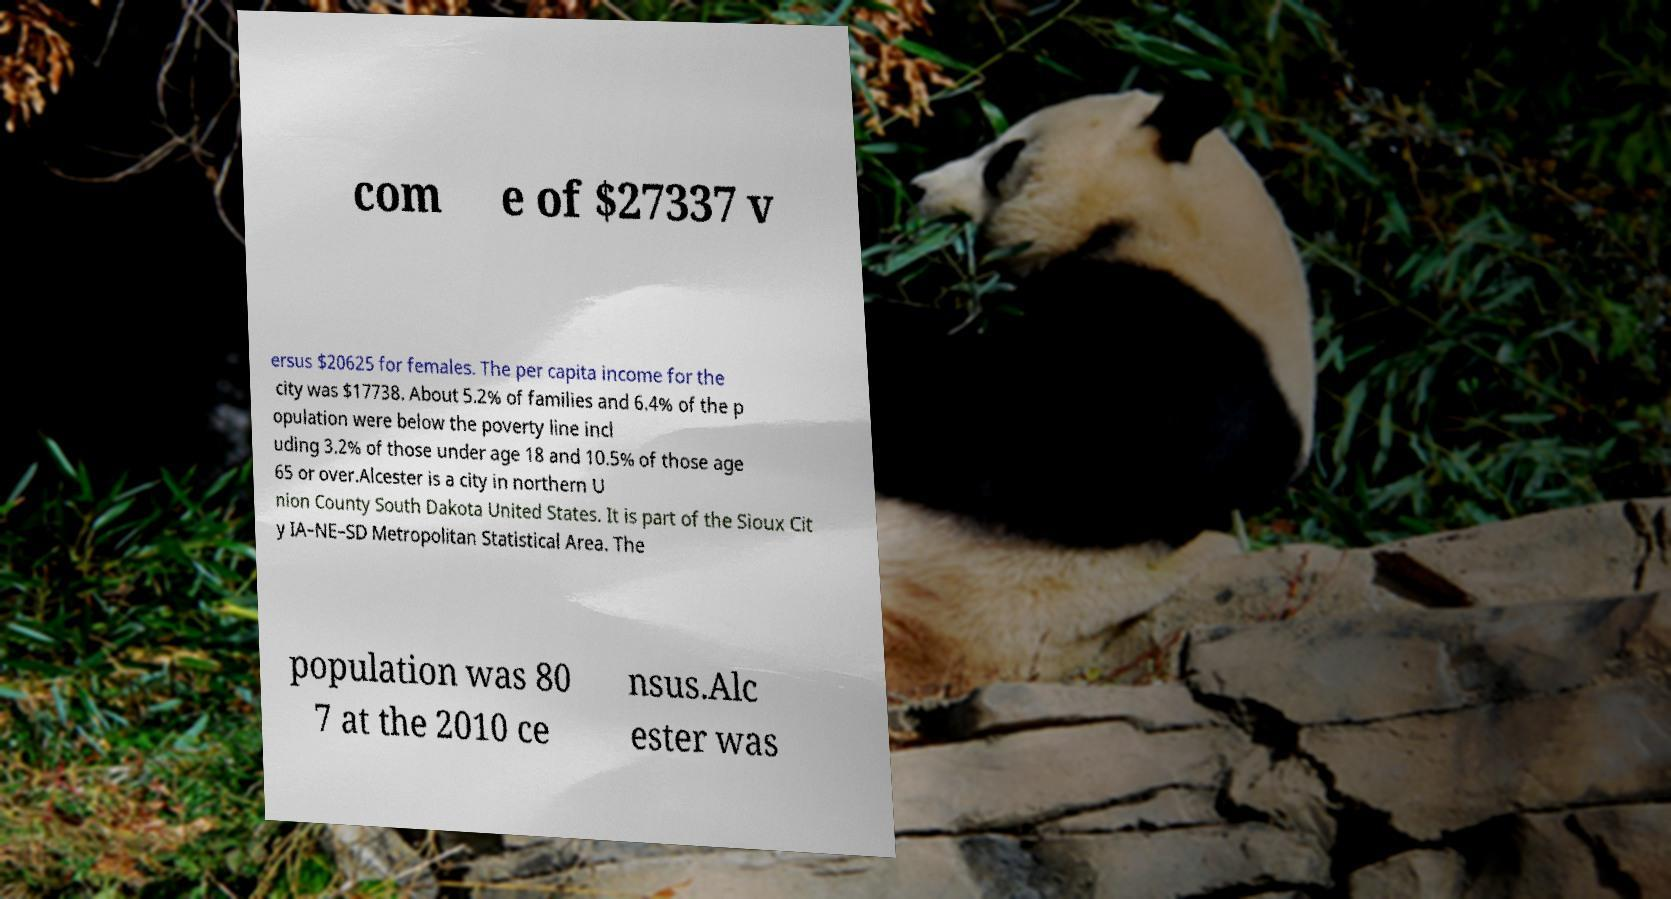Can you read and provide the text displayed in the image?This photo seems to have some interesting text. Can you extract and type it out for me? com e of $27337 v ersus $20625 for females. The per capita income for the city was $17738. About 5.2% of families and 6.4% of the p opulation were below the poverty line incl uding 3.2% of those under age 18 and 10.5% of those age 65 or over.Alcester is a city in northern U nion County South Dakota United States. It is part of the Sioux Cit y IA–NE–SD Metropolitan Statistical Area. The population was 80 7 at the 2010 ce nsus.Alc ester was 